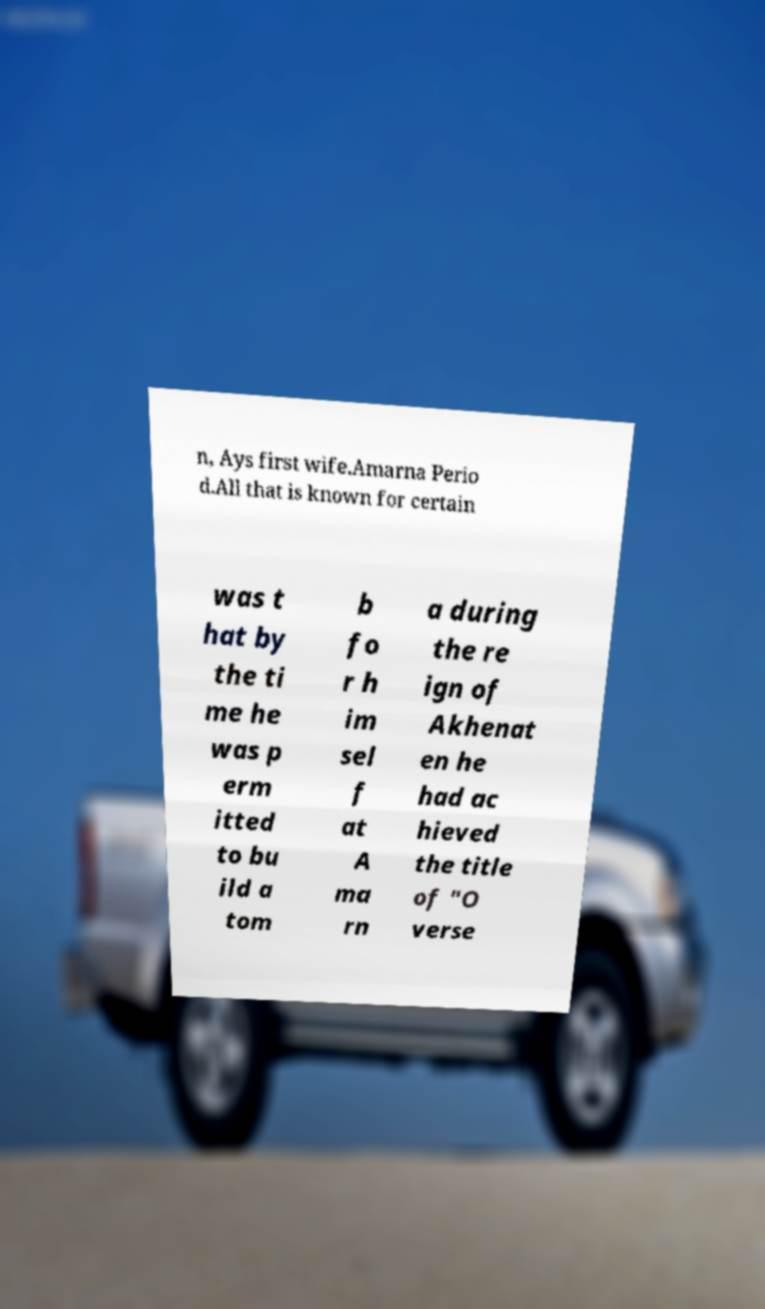Can you accurately transcribe the text from the provided image for me? n, Ays first wife.Amarna Perio d.All that is known for certain was t hat by the ti me he was p erm itted to bu ild a tom b fo r h im sel f at A ma rn a during the re ign of Akhenat en he had ac hieved the title of "O verse 